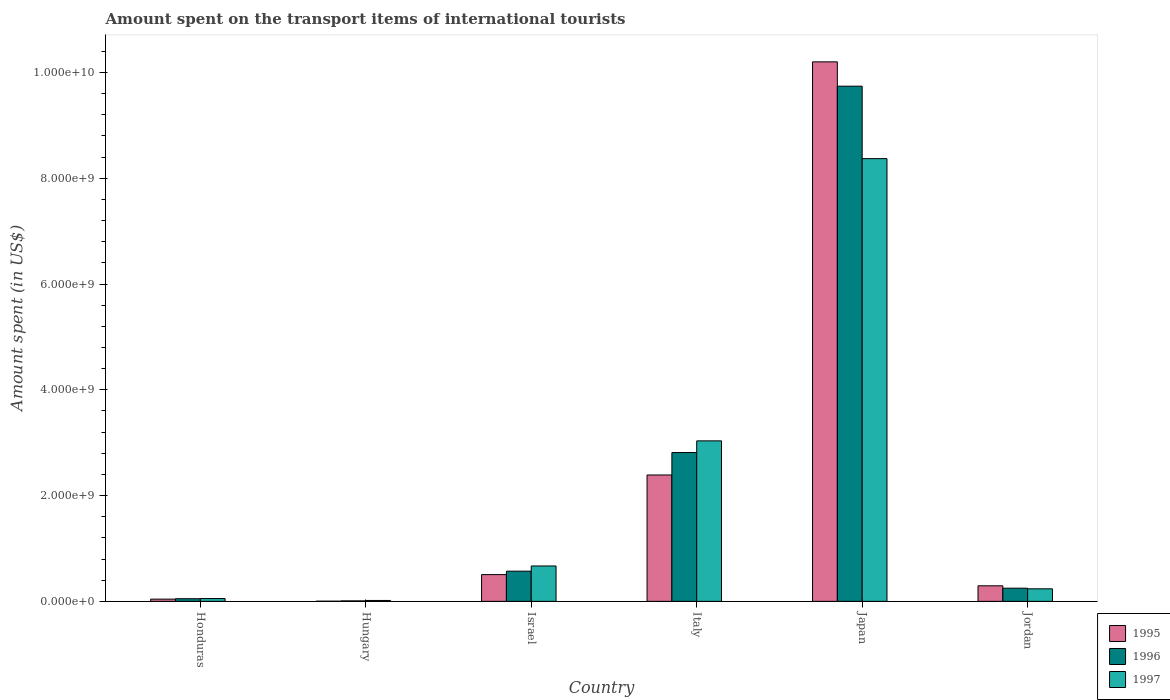How many different coloured bars are there?
Offer a very short reply. 3. Are the number of bars on each tick of the X-axis equal?
Offer a very short reply. Yes. How many bars are there on the 4th tick from the left?
Make the answer very short. 3. What is the label of the 3rd group of bars from the left?
Provide a short and direct response. Israel. What is the amount spent on the transport items of international tourists in 1996 in Italy?
Your answer should be very brief. 2.81e+09. Across all countries, what is the maximum amount spent on the transport items of international tourists in 1997?
Provide a succinct answer. 8.37e+09. In which country was the amount spent on the transport items of international tourists in 1997 maximum?
Your answer should be compact. Japan. In which country was the amount spent on the transport items of international tourists in 1996 minimum?
Give a very brief answer. Hungary. What is the total amount spent on the transport items of international tourists in 1996 in the graph?
Your answer should be compact. 1.34e+1. What is the difference between the amount spent on the transport items of international tourists in 1996 in Italy and that in Japan?
Make the answer very short. -6.93e+09. What is the difference between the amount spent on the transport items of international tourists in 1995 in Italy and the amount spent on the transport items of international tourists in 1997 in Japan?
Keep it short and to the point. -5.98e+09. What is the average amount spent on the transport items of international tourists in 1995 per country?
Provide a short and direct response. 2.24e+09. What is the difference between the amount spent on the transport items of international tourists of/in 1996 and amount spent on the transport items of international tourists of/in 1995 in Honduras?
Provide a short and direct response. 8.00e+06. What is the ratio of the amount spent on the transport items of international tourists in 1996 in Honduras to that in Hungary?
Offer a terse response. 5.56. Is the difference between the amount spent on the transport items of international tourists in 1996 in Honduras and Italy greater than the difference between the amount spent on the transport items of international tourists in 1995 in Honduras and Italy?
Make the answer very short. No. What is the difference between the highest and the second highest amount spent on the transport items of international tourists in 1995?
Your response must be concise. 7.81e+09. What is the difference between the highest and the lowest amount spent on the transport items of international tourists in 1996?
Offer a very short reply. 9.73e+09. What does the 2nd bar from the left in Japan represents?
Make the answer very short. 1996. Are all the bars in the graph horizontal?
Keep it short and to the point. No. How many countries are there in the graph?
Make the answer very short. 6. What is the difference between two consecutive major ticks on the Y-axis?
Make the answer very short. 2.00e+09. What is the title of the graph?
Offer a very short reply. Amount spent on the transport items of international tourists. What is the label or title of the X-axis?
Offer a terse response. Country. What is the label or title of the Y-axis?
Make the answer very short. Amount spent (in US$). What is the Amount spent (in US$) of 1995 in Honduras?
Give a very brief answer. 4.20e+07. What is the Amount spent (in US$) in 1997 in Honduras?
Make the answer very short. 5.30e+07. What is the Amount spent (in US$) in 1995 in Hungary?
Ensure brevity in your answer.  3.00e+06. What is the Amount spent (in US$) in 1996 in Hungary?
Provide a succinct answer. 9.00e+06. What is the Amount spent (in US$) of 1997 in Hungary?
Provide a short and direct response. 1.70e+07. What is the Amount spent (in US$) in 1995 in Israel?
Give a very brief answer. 5.06e+08. What is the Amount spent (in US$) in 1996 in Israel?
Offer a terse response. 5.71e+08. What is the Amount spent (in US$) of 1997 in Israel?
Ensure brevity in your answer.  6.69e+08. What is the Amount spent (in US$) of 1995 in Italy?
Give a very brief answer. 2.39e+09. What is the Amount spent (in US$) of 1996 in Italy?
Give a very brief answer. 2.81e+09. What is the Amount spent (in US$) of 1997 in Italy?
Make the answer very short. 3.04e+09. What is the Amount spent (in US$) in 1995 in Japan?
Ensure brevity in your answer.  1.02e+1. What is the Amount spent (in US$) of 1996 in Japan?
Your answer should be compact. 9.74e+09. What is the Amount spent (in US$) of 1997 in Japan?
Your answer should be very brief. 8.37e+09. What is the Amount spent (in US$) in 1995 in Jordan?
Your answer should be compact. 2.94e+08. What is the Amount spent (in US$) of 1996 in Jordan?
Give a very brief answer. 2.49e+08. What is the Amount spent (in US$) of 1997 in Jordan?
Make the answer very short. 2.37e+08. Across all countries, what is the maximum Amount spent (in US$) in 1995?
Ensure brevity in your answer.  1.02e+1. Across all countries, what is the maximum Amount spent (in US$) of 1996?
Give a very brief answer. 9.74e+09. Across all countries, what is the maximum Amount spent (in US$) in 1997?
Provide a succinct answer. 8.37e+09. Across all countries, what is the minimum Amount spent (in US$) in 1996?
Your answer should be compact. 9.00e+06. Across all countries, what is the minimum Amount spent (in US$) of 1997?
Provide a succinct answer. 1.70e+07. What is the total Amount spent (in US$) of 1995 in the graph?
Give a very brief answer. 1.34e+1. What is the total Amount spent (in US$) of 1996 in the graph?
Ensure brevity in your answer.  1.34e+1. What is the total Amount spent (in US$) in 1997 in the graph?
Offer a terse response. 1.24e+1. What is the difference between the Amount spent (in US$) in 1995 in Honduras and that in Hungary?
Offer a terse response. 3.90e+07. What is the difference between the Amount spent (in US$) in 1996 in Honduras and that in Hungary?
Provide a succinct answer. 4.10e+07. What is the difference between the Amount spent (in US$) in 1997 in Honduras and that in Hungary?
Provide a succinct answer. 3.60e+07. What is the difference between the Amount spent (in US$) of 1995 in Honduras and that in Israel?
Offer a terse response. -4.64e+08. What is the difference between the Amount spent (in US$) of 1996 in Honduras and that in Israel?
Offer a terse response. -5.21e+08. What is the difference between the Amount spent (in US$) in 1997 in Honduras and that in Israel?
Provide a succinct answer. -6.16e+08. What is the difference between the Amount spent (in US$) of 1995 in Honduras and that in Italy?
Offer a very short reply. -2.35e+09. What is the difference between the Amount spent (in US$) in 1996 in Honduras and that in Italy?
Provide a succinct answer. -2.76e+09. What is the difference between the Amount spent (in US$) in 1997 in Honduras and that in Italy?
Ensure brevity in your answer.  -2.98e+09. What is the difference between the Amount spent (in US$) of 1995 in Honduras and that in Japan?
Your response must be concise. -1.02e+1. What is the difference between the Amount spent (in US$) of 1996 in Honduras and that in Japan?
Give a very brief answer. -9.69e+09. What is the difference between the Amount spent (in US$) of 1997 in Honduras and that in Japan?
Ensure brevity in your answer.  -8.32e+09. What is the difference between the Amount spent (in US$) of 1995 in Honduras and that in Jordan?
Keep it short and to the point. -2.52e+08. What is the difference between the Amount spent (in US$) of 1996 in Honduras and that in Jordan?
Give a very brief answer. -1.99e+08. What is the difference between the Amount spent (in US$) of 1997 in Honduras and that in Jordan?
Provide a succinct answer. -1.84e+08. What is the difference between the Amount spent (in US$) of 1995 in Hungary and that in Israel?
Offer a terse response. -5.03e+08. What is the difference between the Amount spent (in US$) of 1996 in Hungary and that in Israel?
Offer a very short reply. -5.62e+08. What is the difference between the Amount spent (in US$) of 1997 in Hungary and that in Israel?
Offer a terse response. -6.52e+08. What is the difference between the Amount spent (in US$) in 1995 in Hungary and that in Italy?
Make the answer very short. -2.39e+09. What is the difference between the Amount spent (in US$) of 1996 in Hungary and that in Italy?
Provide a short and direct response. -2.80e+09. What is the difference between the Amount spent (in US$) of 1997 in Hungary and that in Italy?
Provide a short and direct response. -3.02e+09. What is the difference between the Amount spent (in US$) in 1995 in Hungary and that in Japan?
Your answer should be compact. -1.02e+1. What is the difference between the Amount spent (in US$) of 1996 in Hungary and that in Japan?
Make the answer very short. -9.73e+09. What is the difference between the Amount spent (in US$) of 1997 in Hungary and that in Japan?
Provide a short and direct response. -8.36e+09. What is the difference between the Amount spent (in US$) of 1995 in Hungary and that in Jordan?
Make the answer very short. -2.91e+08. What is the difference between the Amount spent (in US$) of 1996 in Hungary and that in Jordan?
Ensure brevity in your answer.  -2.40e+08. What is the difference between the Amount spent (in US$) of 1997 in Hungary and that in Jordan?
Keep it short and to the point. -2.20e+08. What is the difference between the Amount spent (in US$) of 1995 in Israel and that in Italy?
Provide a short and direct response. -1.88e+09. What is the difference between the Amount spent (in US$) in 1996 in Israel and that in Italy?
Keep it short and to the point. -2.24e+09. What is the difference between the Amount spent (in US$) of 1997 in Israel and that in Italy?
Keep it short and to the point. -2.37e+09. What is the difference between the Amount spent (in US$) in 1995 in Israel and that in Japan?
Give a very brief answer. -9.70e+09. What is the difference between the Amount spent (in US$) of 1996 in Israel and that in Japan?
Offer a very short reply. -9.17e+09. What is the difference between the Amount spent (in US$) of 1997 in Israel and that in Japan?
Offer a very short reply. -7.70e+09. What is the difference between the Amount spent (in US$) of 1995 in Israel and that in Jordan?
Your answer should be very brief. 2.12e+08. What is the difference between the Amount spent (in US$) in 1996 in Israel and that in Jordan?
Your answer should be compact. 3.22e+08. What is the difference between the Amount spent (in US$) in 1997 in Israel and that in Jordan?
Keep it short and to the point. 4.32e+08. What is the difference between the Amount spent (in US$) in 1995 in Italy and that in Japan?
Your response must be concise. -7.81e+09. What is the difference between the Amount spent (in US$) of 1996 in Italy and that in Japan?
Ensure brevity in your answer.  -6.93e+09. What is the difference between the Amount spent (in US$) of 1997 in Italy and that in Japan?
Offer a terse response. -5.34e+09. What is the difference between the Amount spent (in US$) in 1995 in Italy and that in Jordan?
Your answer should be compact. 2.10e+09. What is the difference between the Amount spent (in US$) in 1996 in Italy and that in Jordan?
Keep it short and to the point. 2.56e+09. What is the difference between the Amount spent (in US$) of 1997 in Italy and that in Jordan?
Offer a very short reply. 2.80e+09. What is the difference between the Amount spent (in US$) of 1995 in Japan and that in Jordan?
Offer a very short reply. 9.91e+09. What is the difference between the Amount spent (in US$) in 1996 in Japan and that in Jordan?
Your answer should be very brief. 9.49e+09. What is the difference between the Amount spent (in US$) in 1997 in Japan and that in Jordan?
Make the answer very short. 8.14e+09. What is the difference between the Amount spent (in US$) of 1995 in Honduras and the Amount spent (in US$) of 1996 in Hungary?
Offer a very short reply. 3.30e+07. What is the difference between the Amount spent (in US$) of 1995 in Honduras and the Amount spent (in US$) of 1997 in Hungary?
Ensure brevity in your answer.  2.50e+07. What is the difference between the Amount spent (in US$) of 1996 in Honduras and the Amount spent (in US$) of 1997 in Hungary?
Give a very brief answer. 3.30e+07. What is the difference between the Amount spent (in US$) in 1995 in Honduras and the Amount spent (in US$) in 1996 in Israel?
Provide a succinct answer. -5.29e+08. What is the difference between the Amount spent (in US$) of 1995 in Honduras and the Amount spent (in US$) of 1997 in Israel?
Your answer should be very brief. -6.27e+08. What is the difference between the Amount spent (in US$) of 1996 in Honduras and the Amount spent (in US$) of 1997 in Israel?
Keep it short and to the point. -6.19e+08. What is the difference between the Amount spent (in US$) in 1995 in Honduras and the Amount spent (in US$) in 1996 in Italy?
Your answer should be very brief. -2.77e+09. What is the difference between the Amount spent (in US$) of 1995 in Honduras and the Amount spent (in US$) of 1997 in Italy?
Give a very brief answer. -2.99e+09. What is the difference between the Amount spent (in US$) in 1996 in Honduras and the Amount spent (in US$) in 1997 in Italy?
Your answer should be very brief. -2.98e+09. What is the difference between the Amount spent (in US$) in 1995 in Honduras and the Amount spent (in US$) in 1996 in Japan?
Provide a short and direct response. -9.70e+09. What is the difference between the Amount spent (in US$) in 1995 in Honduras and the Amount spent (in US$) in 1997 in Japan?
Your answer should be very brief. -8.33e+09. What is the difference between the Amount spent (in US$) of 1996 in Honduras and the Amount spent (in US$) of 1997 in Japan?
Your answer should be compact. -8.32e+09. What is the difference between the Amount spent (in US$) of 1995 in Honduras and the Amount spent (in US$) of 1996 in Jordan?
Provide a short and direct response. -2.07e+08. What is the difference between the Amount spent (in US$) in 1995 in Honduras and the Amount spent (in US$) in 1997 in Jordan?
Offer a terse response. -1.95e+08. What is the difference between the Amount spent (in US$) of 1996 in Honduras and the Amount spent (in US$) of 1997 in Jordan?
Offer a very short reply. -1.87e+08. What is the difference between the Amount spent (in US$) of 1995 in Hungary and the Amount spent (in US$) of 1996 in Israel?
Make the answer very short. -5.68e+08. What is the difference between the Amount spent (in US$) of 1995 in Hungary and the Amount spent (in US$) of 1997 in Israel?
Make the answer very short. -6.66e+08. What is the difference between the Amount spent (in US$) in 1996 in Hungary and the Amount spent (in US$) in 1997 in Israel?
Keep it short and to the point. -6.60e+08. What is the difference between the Amount spent (in US$) in 1995 in Hungary and the Amount spent (in US$) in 1996 in Italy?
Make the answer very short. -2.81e+09. What is the difference between the Amount spent (in US$) in 1995 in Hungary and the Amount spent (in US$) in 1997 in Italy?
Offer a terse response. -3.03e+09. What is the difference between the Amount spent (in US$) of 1996 in Hungary and the Amount spent (in US$) of 1997 in Italy?
Your answer should be very brief. -3.03e+09. What is the difference between the Amount spent (in US$) in 1995 in Hungary and the Amount spent (in US$) in 1996 in Japan?
Offer a terse response. -9.74e+09. What is the difference between the Amount spent (in US$) in 1995 in Hungary and the Amount spent (in US$) in 1997 in Japan?
Make the answer very short. -8.37e+09. What is the difference between the Amount spent (in US$) of 1996 in Hungary and the Amount spent (in US$) of 1997 in Japan?
Give a very brief answer. -8.36e+09. What is the difference between the Amount spent (in US$) of 1995 in Hungary and the Amount spent (in US$) of 1996 in Jordan?
Offer a terse response. -2.46e+08. What is the difference between the Amount spent (in US$) of 1995 in Hungary and the Amount spent (in US$) of 1997 in Jordan?
Make the answer very short. -2.34e+08. What is the difference between the Amount spent (in US$) of 1996 in Hungary and the Amount spent (in US$) of 1997 in Jordan?
Your response must be concise. -2.28e+08. What is the difference between the Amount spent (in US$) in 1995 in Israel and the Amount spent (in US$) in 1996 in Italy?
Your answer should be very brief. -2.31e+09. What is the difference between the Amount spent (in US$) in 1995 in Israel and the Amount spent (in US$) in 1997 in Italy?
Offer a terse response. -2.53e+09. What is the difference between the Amount spent (in US$) in 1996 in Israel and the Amount spent (in US$) in 1997 in Italy?
Your answer should be compact. -2.46e+09. What is the difference between the Amount spent (in US$) in 1995 in Israel and the Amount spent (in US$) in 1996 in Japan?
Keep it short and to the point. -9.24e+09. What is the difference between the Amount spent (in US$) of 1995 in Israel and the Amount spent (in US$) of 1997 in Japan?
Give a very brief answer. -7.87e+09. What is the difference between the Amount spent (in US$) in 1996 in Israel and the Amount spent (in US$) in 1997 in Japan?
Give a very brief answer. -7.80e+09. What is the difference between the Amount spent (in US$) of 1995 in Israel and the Amount spent (in US$) of 1996 in Jordan?
Give a very brief answer. 2.57e+08. What is the difference between the Amount spent (in US$) in 1995 in Israel and the Amount spent (in US$) in 1997 in Jordan?
Your answer should be compact. 2.69e+08. What is the difference between the Amount spent (in US$) of 1996 in Israel and the Amount spent (in US$) of 1997 in Jordan?
Your answer should be very brief. 3.34e+08. What is the difference between the Amount spent (in US$) in 1995 in Italy and the Amount spent (in US$) in 1996 in Japan?
Keep it short and to the point. -7.35e+09. What is the difference between the Amount spent (in US$) of 1995 in Italy and the Amount spent (in US$) of 1997 in Japan?
Offer a very short reply. -5.98e+09. What is the difference between the Amount spent (in US$) of 1996 in Italy and the Amount spent (in US$) of 1997 in Japan?
Your answer should be very brief. -5.56e+09. What is the difference between the Amount spent (in US$) of 1995 in Italy and the Amount spent (in US$) of 1996 in Jordan?
Make the answer very short. 2.14e+09. What is the difference between the Amount spent (in US$) of 1995 in Italy and the Amount spent (in US$) of 1997 in Jordan?
Your response must be concise. 2.15e+09. What is the difference between the Amount spent (in US$) of 1996 in Italy and the Amount spent (in US$) of 1997 in Jordan?
Give a very brief answer. 2.58e+09. What is the difference between the Amount spent (in US$) of 1995 in Japan and the Amount spent (in US$) of 1996 in Jordan?
Provide a short and direct response. 9.95e+09. What is the difference between the Amount spent (in US$) of 1995 in Japan and the Amount spent (in US$) of 1997 in Jordan?
Provide a short and direct response. 9.96e+09. What is the difference between the Amount spent (in US$) of 1996 in Japan and the Amount spent (in US$) of 1997 in Jordan?
Your answer should be very brief. 9.50e+09. What is the average Amount spent (in US$) in 1995 per country?
Make the answer very short. 2.24e+09. What is the average Amount spent (in US$) of 1996 per country?
Keep it short and to the point. 2.24e+09. What is the average Amount spent (in US$) in 1997 per country?
Keep it short and to the point. 2.06e+09. What is the difference between the Amount spent (in US$) of 1995 and Amount spent (in US$) of 1996 in Honduras?
Keep it short and to the point. -8.00e+06. What is the difference between the Amount spent (in US$) in 1995 and Amount spent (in US$) in 1997 in Honduras?
Your answer should be very brief. -1.10e+07. What is the difference between the Amount spent (in US$) of 1995 and Amount spent (in US$) of 1996 in Hungary?
Provide a short and direct response. -6.00e+06. What is the difference between the Amount spent (in US$) of 1995 and Amount spent (in US$) of 1997 in Hungary?
Your answer should be compact. -1.40e+07. What is the difference between the Amount spent (in US$) in 1996 and Amount spent (in US$) in 1997 in Hungary?
Provide a succinct answer. -8.00e+06. What is the difference between the Amount spent (in US$) of 1995 and Amount spent (in US$) of 1996 in Israel?
Your answer should be compact. -6.50e+07. What is the difference between the Amount spent (in US$) of 1995 and Amount spent (in US$) of 1997 in Israel?
Provide a succinct answer. -1.63e+08. What is the difference between the Amount spent (in US$) in 1996 and Amount spent (in US$) in 1997 in Israel?
Your response must be concise. -9.80e+07. What is the difference between the Amount spent (in US$) of 1995 and Amount spent (in US$) of 1996 in Italy?
Give a very brief answer. -4.24e+08. What is the difference between the Amount spent (in US$) in 1995 and Amount spent (in US$) in 1997 in Italy?
Provide a succinct answer. -6.45e+08. What is the difference between the Amount spent (in US$) in 1996 and Amount spent (in US$) in 1997 in Italy?
Offer a terse response. -2.21e+08. What is the difference between the Amount spent (in US$) of 1995 and Amount spent (in US$) of 1996 in Japan?
Provide a succinct answer. 4.60e+08. What is the difference between the Amount spent (in US$) in 1995 and Amount spent (in US$) in 1997 in Japan?
Provide a succinct answer. 1.83e+09. What is the difference between the Amount spent (in US$) in 1996 and Amount spent (in US$) in 1997 in Japan?
Provide a succinct answer. 1.37e+09. What is the difference between the Amount spent (in US$) in 1995 and Amount spent (in US$) in 1996 in Jordan?
Offer a very short reply. 4.50e+07. What is the difference between the Amount spent (in US$) of 1995 and Amount spent (in US$) of 1997 in Jordan?
Offer a terse response. 5.70e+07. What is the ratio of the Amount spent (in US$) of 1995 in Honduras to that in Hungary?
Your answer should be very brief. 14. What is the ratio of the Amount spent (in US$) of 1996 in Honduras to that in Hungary?
Make the answer very short. 5.56. What is the ratio of the Amount spent (in US$) in 1997 in Honduras to that in Hungary?
Offer a terse response. 3.12. What is the ratio of the Amount spent (in US$) in 1995 in Honduras to that in Israel?
Offer a terse response. 0.08. What is the ratio of the Amount spent (in US$) in 1996 in Honduras to that in Israel?
Your response must be concise. 0.09. What is the ratio of the Amount spent (in US$) of 1997 in Honduras to that in Israel?
Ensure brevity in your answer.  0.08. What is the ratio of the Amount spent (in US$) in 1995 in Honduras to that in Italy?
Your answer should be compact. 0.02. What is the ratio of the Amount spent (in US$) of 1996 in Honduras to that in Italy?
Make the answer very short. 0.02. What is the ratio of the Amount spent (in US$) of 1997 in Honduras to that in Italy?
Your answer should be very brief. 0.02. What is the ratio of the Amount spent (in US$) in 1995 in Honduras to that in Japan?
Ensure brevity in your answer.  0. What is the ratio of the Amount spent (in US$) of 1996 in Honduras to that in Japan?
Offer a terse response. 0.01. What is the ratio of the Amount spent (in US$) of 1997 in Honduras to that in Japan?
Offer a very short reply. 0.01. What is the ratio of the Amount spent (in US$) in 1995 in Honduras to that in Jordan?
Make the answer very short. 0.14. What is the ratio of the Amount spent (in US$) in 1996 in Honduras to that in Jordan?
Your answer should be very brief. 0.2. What is the ratio of the Amount spent (in US$) in 1997 in Honduras to that in Jordan?
Your response must be concise. 0.22. What is the ratio of the Amount spent (in US$) in 1995 in Hungary to that in Israel?
Your answer should be compact. 0.01. What is the ratio of the Amount spent (in US$) in 1996 in Hungary to that in Israel?
Keep it short and to the point. 0.02. What is the ratio of the Amount spent (in US$) in 1997 in Hungary to that in Israel?
Ensure brevity in your answer.  0.03. What is the ratio of the Amount spent (in US$) in 1995 in Hungary to that in Italy?
Your answer should be compact. 0. What is the ratio of the Amount spent (in US$) of 1996 in Hungary to that in Italy?
Your response must be concise. 0. What is the ratio of the Amount spent (in US$) of 1997 in Hungary to that in Italy?
Your answer should be very brief. 0.01. What is the ratio of the Amount spent (in US$) of 1996 in Hungary to that in Japan?
Ensure brevity in your answer.  0. What is the ratio of the Amount spent (in US$) of 1997 in Hungary to that in Japan?
Provide a succinct answer. 0. What is the ratio of the Amount spent (in US$) in 1995 in Hungary to that in Jordan?
Your answer should be very brief. 0.01. What is the ratio of the Amount spent (in US$) of 1996 in Hungary to that in Jordan?
Provide a succinct answer. 0.04. What is the ratio of the Amount spent (in US$) in 1997 in Hungary to that in Jordan?
Ensure brevity in your answer.  0.07. What is the ratio of the Amount spent (in US$) in 1995 in Israel to that in Italy?
Your answer should be compact. 0.21. What is the ratio of the Amount spent (in US$) of 1996 in Israel to that in Italy?
Provide a short and direct response. 0.2. What is the ratio of the Amount spent (in US$) of 1997 in Israel to that in Italy?
Make the answer very short. 0.22. What is the ratio of the Amount spent (in US$) in 1995 in Israel to that in Japan?
Provide a short and direct response. 0.05. What is the ratio of the Amount spent (in US$) in 1996 in Israel to that in Japan?
Make the answer very short. 0.06. What is the ratio of the Amount spent (in US$) of 1997 in Israel to that in Japan?
Give a very brief answer. 0.08. What is the ratio of the Amount spent (in US$) of 1995 in Israel to that in Jordan?
Give a very brief answer. 1.72. What is the ratio of the Amount spent (in US$) in 1996 in Israel to that in Jordan?
Offer a very short reply. 2.29. What is the ratio of the Amount spent (in US$) in 1997 in Israel to that in Jordan?
Provide a short and direct response. 2.82. What is the ratio of the Amount spent (in US$) of 1995 in Italy to that in Japan?
Offer a very short reply. 0.23. What is the ratio of the Amount spent (in US$) of 1996 in Italy to that in Japan?
Your response must be concise. 0.29. What is the ratio of the Amount spent (in US$) of 1997 in Italy to that in Japan?
Your answer should be compact. 0.36. What is the ratio of the Amount spent (in US$) in 1995 in Italy to that in Jordan?
Make the answer very short. 8.13. What is the ratio of the Amount spent (in US$) in 1996 in Italy to that in Jordan?
Provide a short and direct response. 11.3. What is the ratio of the Amount spent (in US$) in 1997 in Italy to that in Jordan?
Make the answer very short. 12.81. What is the ratio of the Amount spent (in US$) in 1995 in Japan to that in Jordan?
Provide a short and direct response. 34.7. What is the ratio of the Amount spent (in US$) of 1996 in Japan to that in Jordan?
Provide a short and direct response. 39.12. What is the ratio of the Amount spent (in US$) of 1997 in Japan to that in Jordan?
Offer a very short reply. 35.32. What is the difference between the highest and the second highest Amount spent (in US$) of 1995?
Offer a very short reply. 7.81e+09. What is the difference between the highest and the second highest Amount spent (in US$) in 1996?
Your answer should be compact. 6.93e+09. What is the difference between the highest and the second highest Amount spent (in US$) in 1997?
Your response must be concise. 5.34e+09. What is the difference between the highest and the lowest Amount spent (in US$) of 1995?
Your answer should be compact. 1.02e+1. What is the difference between the highest and the lowest Amount spent (in US$) of 1996?
Your response must be concise. 9.73e+09. What is the difference between the highest and the lowest Amount spent (in US$) of 1997?
Give a very brief answer. 8.36e+09. 